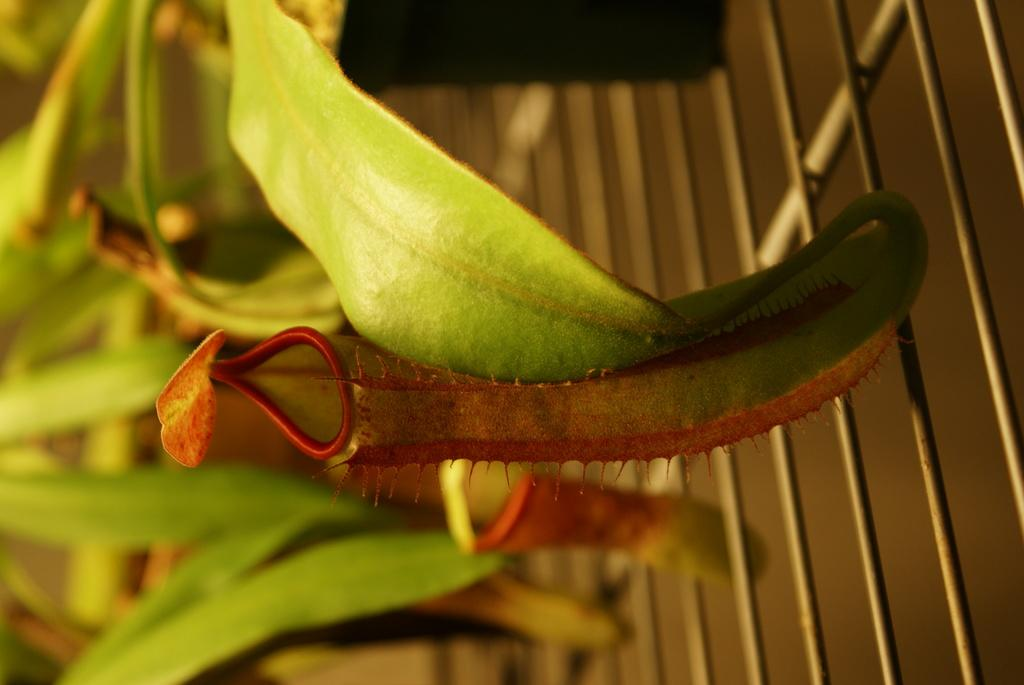What type of vegetation is present in the image? There are green leaves in the image. What can be seen in the image that might be used for cooking? There is a grill in the image. Can you describe the background of the image? The background of the image appears blurred. What type of day is depicted in the image? There is no information about the day in the image, as it only shows green leaves and a grill. Can you tell me where the park is located in the image? There is no park present in the image; it only shows green leaves and a grill. 